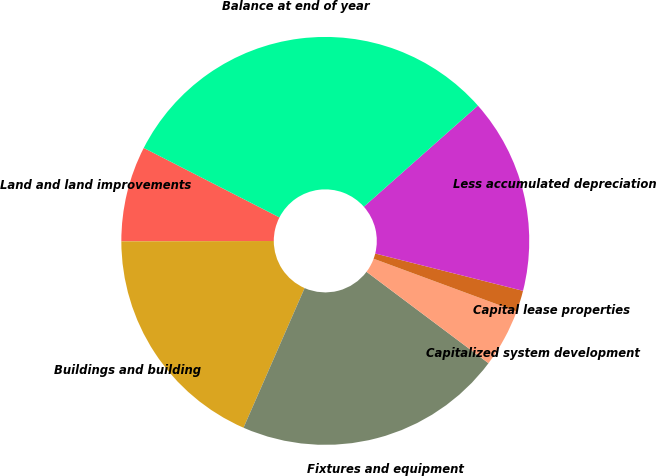<chart> <loc_0><loc_0><loc_500><loc_500><pie_chart><fcel>Land and land improvements<fcel>Buildings and building<fcel>Fixtures and equipment<fcel>Capitalized system development<fcel>Capital lease properties<fcel>Less accumulated depreciation<fcel>Balance at end of year<nl><fcel>7.57%<fcel>18.4%<fcel>21.33%<fcel>4.61%<fcel>1.69%<fcel>15.48%<fcel>30.93%<nl></chart> 